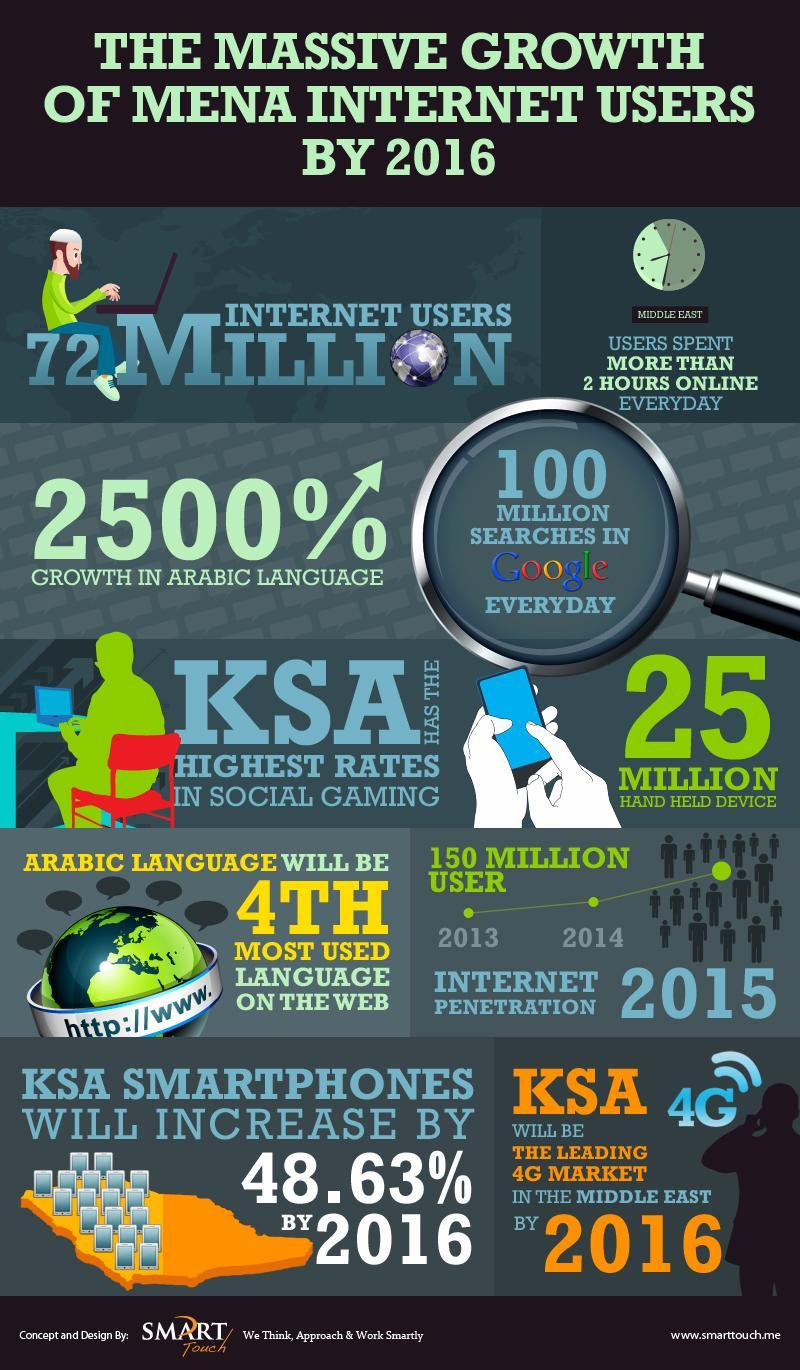In which year did the number of users reach 150 million?
Answer the question with a short phrase. 2015 